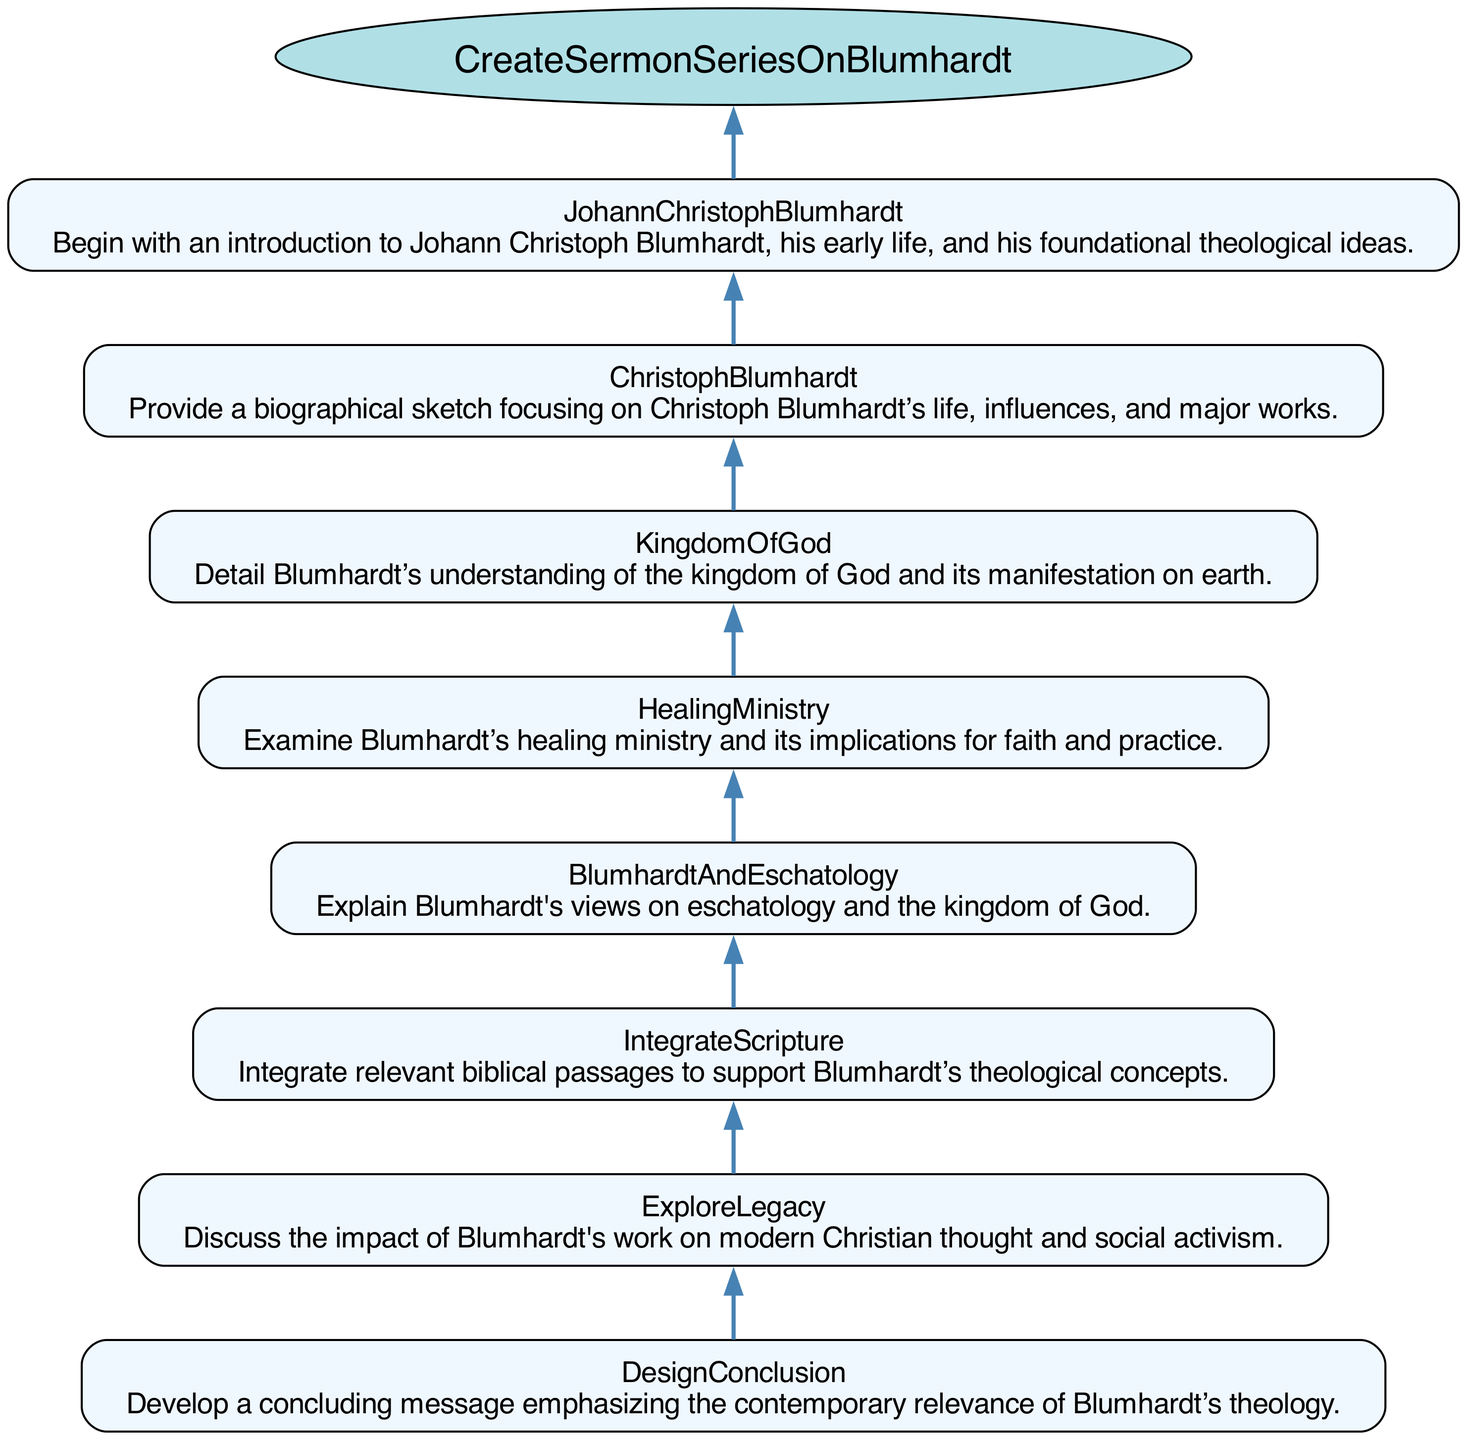What is the first step of the sermon series creation? The first step is to begin with an introduction to Johann Christoph Blumhardt, focusing on his early life and foundational theological ideas. This is evident as it's positioned at the bottom of the flowchart.
Answer: Johann Christoph Blumhardt How many steps are there in the function? The function includes a total of eight distinct steps. This can be determined by counting the steps listed in the diagram.
Answer: 8 What does the last step of the function aim to develop? The last step aims to develop a concluding message that emphasizes the contemporary relevance of Blumhardt’s theology. This is described as the final action in the flowchart.
Answer: Concluding message Which step discusses Blumhardt’s healing ministry? The step that examines Blumhardt’s healing ministry is specifically titled "Healing Ministry". It can be identified by looking through the steps listed in the diagram.
Answer: Healing Ministry Which two steps are directly connected? The step "Explore Legacy" is directly connected to the previous step "Integrate Scripture", as there is a direct edge from "Integrate Scripture" to "Explore Legacy" in the flowchart.
Answer: Explore Legacy and Integrate Scripture How does the function conclude? The function concludes by developing a concluding message that emphasizes the relevance of Blumhardt’s theology today. This is clearly outlined as the final step of the flowchart.
Answer: Develop a concluding message What is the primary subject of the sermon series? The primary subject of the sermon series is exploring Blumhardt's theology, as indicated by the function name at the top of the flowchart.
Answer: Blumhardt's theology Which step precedes the exploration of the kingdom of God? The step that comes right before the exploration of the kingdom of God is "Healing Ministry". This can be confirmed by the sequential arrangement in the flowchart.
Answer: Healing Ministry 